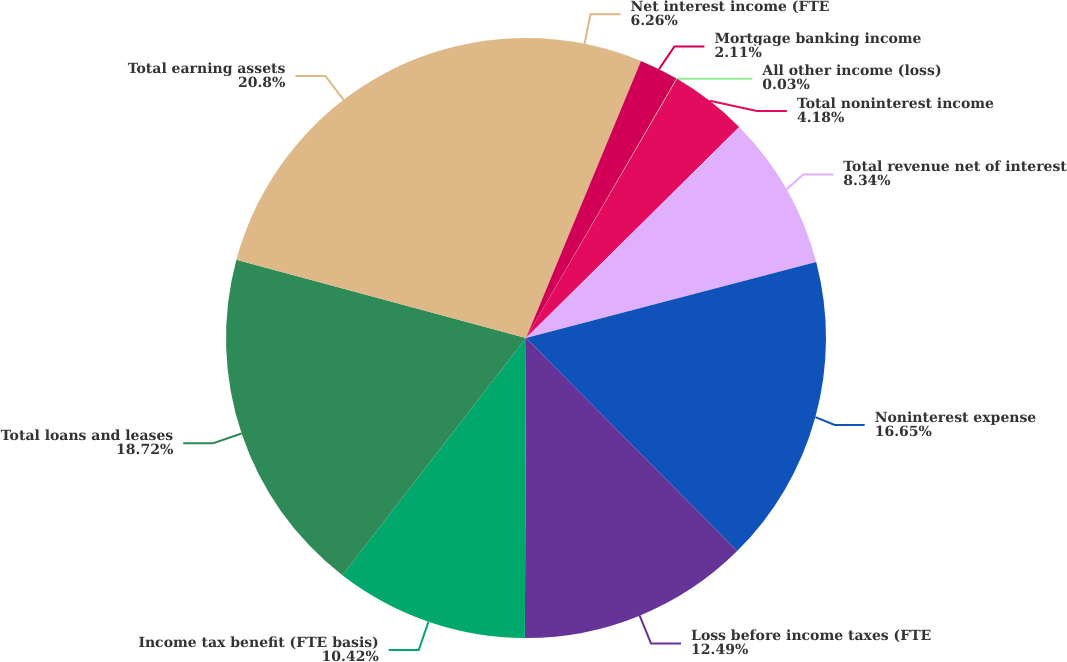<chart> <loc_0><loc_0><loc_500><loc_500><pie_chart><fcel>Net interest income (FTE<fcel>Mortgage banking income<fcel>All other income (loss)<fcel>Total noninterest income<fcel>Total revenue net of interest<fcel>Noninterest expense<fcel>Loss before income taxes (FTE<fcel>Income tax benefit (FTE basis)<fcel>Total loans and leases<fcel>Total earning assets<nl><fcel>6.26%<fcel>2.11%<fcel>0.03%<fcel>4.18%<fcel>8.34%<fcel>16.65%<fcel>12.49%<fcel>10.42%<fcel>18.72%<fcel>20.8%<nl></chart> 